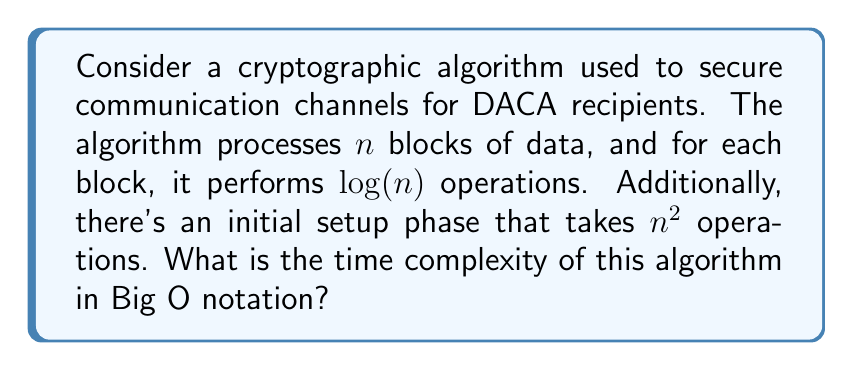Can you answer this question? Let's break this down step-by-step:

1) First, we identify the two main components of the algorithm:
   a) The initial setup phase: $n^2$ operations
   b) The processing of $n$ blocks, each requiring $\log(n)$ operations

2) For the processing part, we need to multiply the number of blocks by the operations per block:
   $n \cdot \log(n)$

3) Now we have two terms to consider:
   $n^2$ (for setup) and $n \log(n)$ (for processing)

4) In Big O notation, we keep only the dominant term as $n$ grows large. To determine which term dominates, we can compare them:

   $\lim_{n \to \infty} \frac{n^2}{n \log(n)} = \lim_{n \to \infty} \frac{n}{\log(n)} = \infty$

5) This limit shows that $n^2$ grows faster than $n \log(n)$ as $n$ approaches infinity.

6) Therefore, the $n^2$ term dominates, and we can express the overall time complexity as $O(n^2)$.
Answer: $O(n^2)$ 